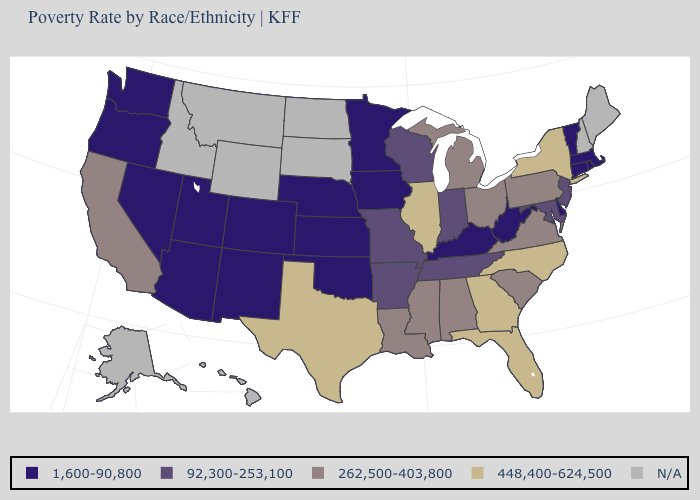Name the states that have a value in the range 1,600-90,800?
Concise answer only. Arizona, Colorado, Connecticut, Delaware, Iowa, Kansas, Kentucky, Massachusetts, Minnesota, Nebraska, Nevada, New Mexico, Oklahoma, Oregon, Rhode Island, Utah, Vermont, Washington, West Virginia. What is the lowest value in the USA?
Be succinct. 1,600-90,800. What is the value of Maine?
Concise answer only. N/A. Name the states that have a value in the range N/A?
Quick response, please. Alaska, Hawaii, Idaho, Maine, Montana, New Hampshire, North Dakota, South Dakota, Wyoming. Name the states that have a value in the range 448,400-624,500?
Be succinct. Florida, Georgia, Illinois, New York, North Carolina, Texas. Among the states that border Connecticut , which have the highest value?
Quick response, please. New York. What is the highest value in the MidWest ?
Short answer required. 448,400-624,500. How many symbols are there in the legend?
Short answer required. 5. Does Louisiana have the highest value in the South?
Answer briefly. No. What is the highest value in states that border Wyoming?
Give a very brief answer. 1,600-90,800. What is the value of Oregon?
Short answer required. 1,600-90,800. Name the states that have a value in the range 262,500-403,800?
Answer briefly. Alabama, California, Louisiana, Michigan, Mississippi, Ohio, Pennsylvania, South Carolina, Virginia. Name the states that have a value in the range 1,600-90,800?
Write a very short answer. Arizona, Colorado, Connecticut, Delaware, Iowa, Kansas, Kentucky, Massachusetts, Minnesota, Nebraska, Nevada, New Mexico, Oklahoma, Oregon, Rhode Island, Utah, Vermont, Washington, West Virginia. 